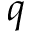<formula> <loc_0><loc_0><loc_500><loc_500>q</formula> 